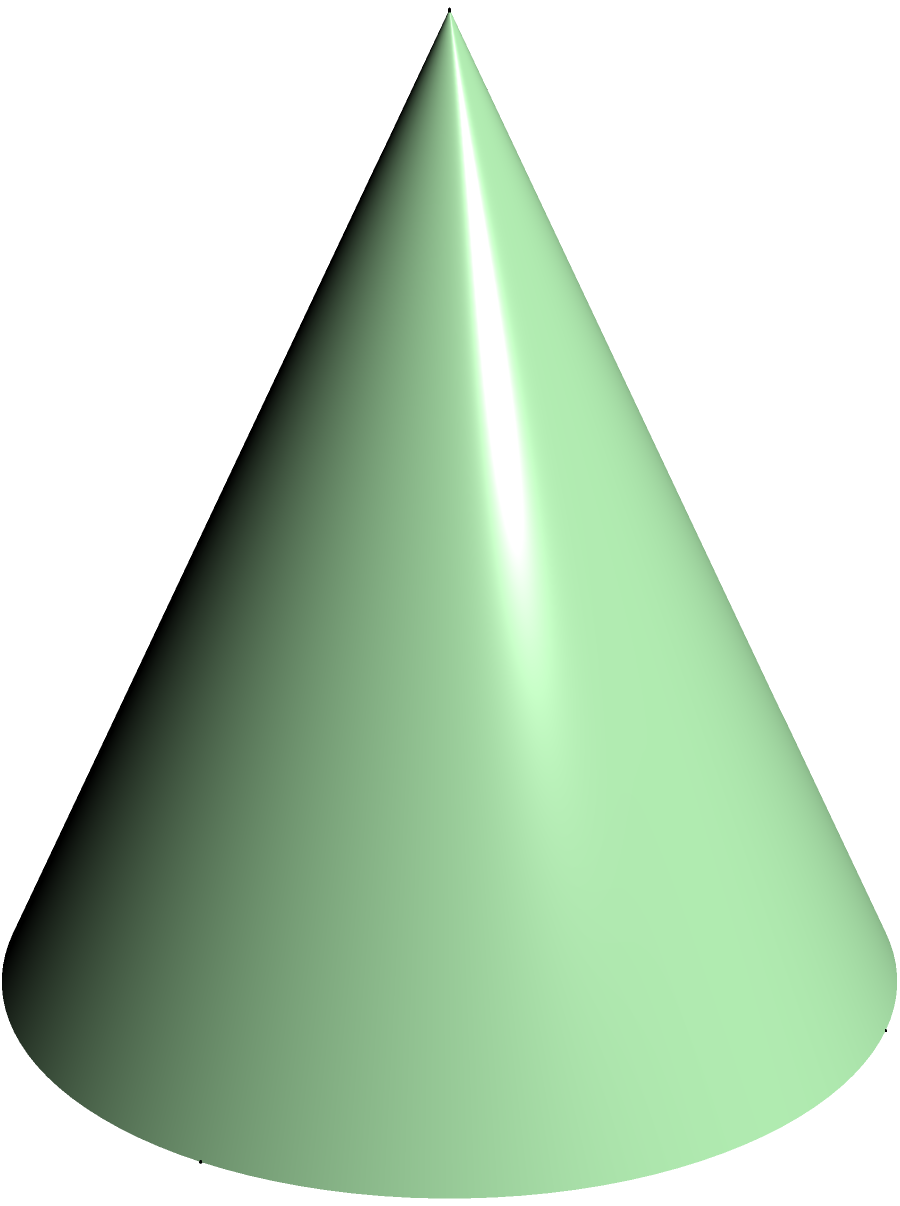As a local farmer in Bukidnon, you've harvested your corn crop and piled it into a conical shape. The pile has a base radius of 2 meters and a height of 4 meters. Calculate the surface area of this conical pile of corn, excluding the circular base. Round your answer to the nearest square meter. To calculate the surface area of a conical pile (excluding the base), we'll use the formula for the lateral surface area of a cone:

$$A = \pi rs$$

Where:
$A$ = lateral surface area
$r$ = radius of the base
$s$ = slant height of the cone

We're given:
$r = 2$ meters
$h = 4$ meters (height)

Step 1: Calculate the slant height ($s$) using the Pythagorean theorem:
$$s^2 = r^2 + h^2$$
$$s^2 = 2^2 + 4^2 = 4 + 16 = 20$$
$$s = \sqrt{20} \approx 4.47 \text{ meters}$$

Step 2: Apply the formula for lateral surface area:
$$A = \pi rs$$
$$A = \pi \cdot 2 \cdot 4.47$$
$$A \approx 28.12 \text{ square meters}$$

Step 3: Round to the nearest square meter:
$$A \approx 28 \text{ square meters}$$
Answer: 28 square meters 